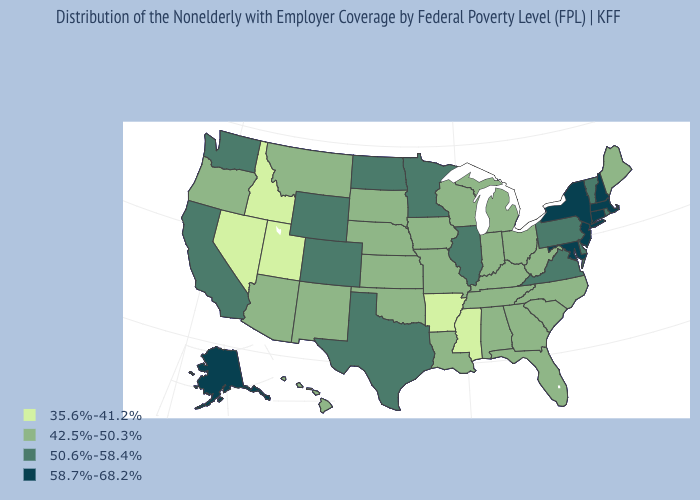What is the highest value in states that border Vermont?
Keep it brief. 58.7%-68.2%. Does Wyoming have a lower value than Alaska?
Be succinct. Yes. Which states hav the highest value in the MidWest?
Concise answer only. Illinois, Minnesota, North Dakota. What is the value of Minnesota?
Write a very short answer. 50.6%-58.4%. Which states have the highest value in the USA?
Quick response, please. Alaska, Connecticut, Maryland, Massachusetts, New Hampshire, New Jersey, New York. Which states hav the highest value in the MidWest?
Be succinct. Illinois, Minnesota, North Dakota. Does New Hampshire have the highest value in the USA?
Quick response, please. Yes. Name the states that have a value in the range 35.6%-41.2%?
Be succinct. Arkansas, Idaho, Mississippi, Nevada, Utah. Name the states that have a value in the range 42.5%-50.3%?
Short answer required. Alabama, Arizona, Florida, Georgia, Hawaii, Indiana, Iowa, Kansas, Kentucky, Louisiana, Maine, Michigan, Missouri, Montana, Nebraska, New Mexico, North Carolina, Ohio, Oklahoma, Oregon, South Carolina, South Dakota, Tennessee, West Virginia, Wisconsin. Name the states that have a value in the range 58.7%-68.2%?
Concise answer only. Alaska, Connecticut, Maryland, Massachusetts, New Hampshire, New Jersey, New York. Does Iowa have the highest value in the MidWest?
Give a very brief answer. No. What is the value of Wisconsin?
Concise answer only. 42.5%-50.3%. What is the value of Massachusetts?
Answer briefly. 58.7%-68.2%. Name the states that have a value in the range 58.7%-68.2%?
Short answer required. Alaska, Connecticut, Maryland, Massachusetts, New Hampshire, New Jersey, New York. Does North Dakota have the highest value in the MidWest?
Give a very brief answer. Yes. 